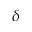Convert formula to latex. <formula><loc_0><loc_0><loc_500><loc_500>\delta</formula> 